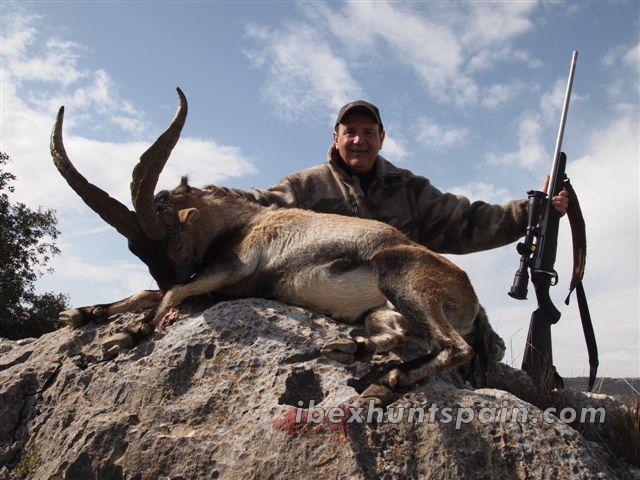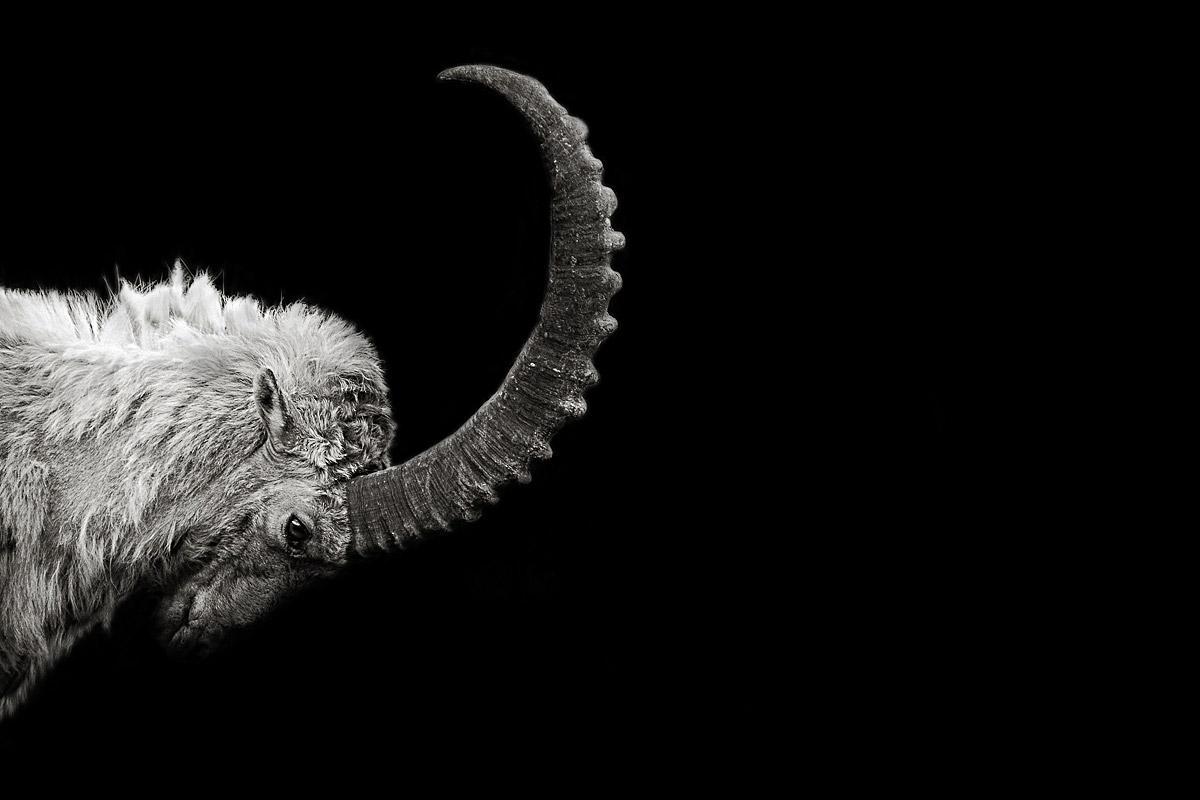The first image is the image on the left, the second image is the image on the right. Assess this claim about the two images: "There is a single animal standing in a rocky area in the image on the left.". Correct or not? Answer yes or no. No. The first image is the image on the left, the second image is the image on the right. Assess this claim about the two images: "An image shows a ram with its head in profile, in a stark scene with no trees or green vegetation.". Correct or not? Answer yes or no. Yes. 